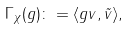<formula> <loc_0><loc_0><loc_500><loc_500>\Gamma _ { \chi } ( g ) \colon = \langle g v , \tilde { v } \rangle ,</formula> 